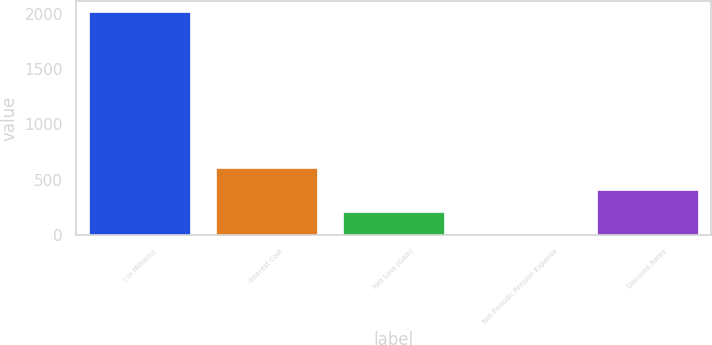Convert chart to OTSL. <chart><loc_0><loc_0><loc_500><loc_500><bar_chart><fcel>( In Millions)<fcel>Interest Cost<fcel>Net Loss (Gain)<fcel>Net Periodic Pension Expense<fcel>Discount Rates<nl><fcel>2015<fcel>605.41<fcel>202.67<fcel>1.3<fcel>404.04<nl></chart> 